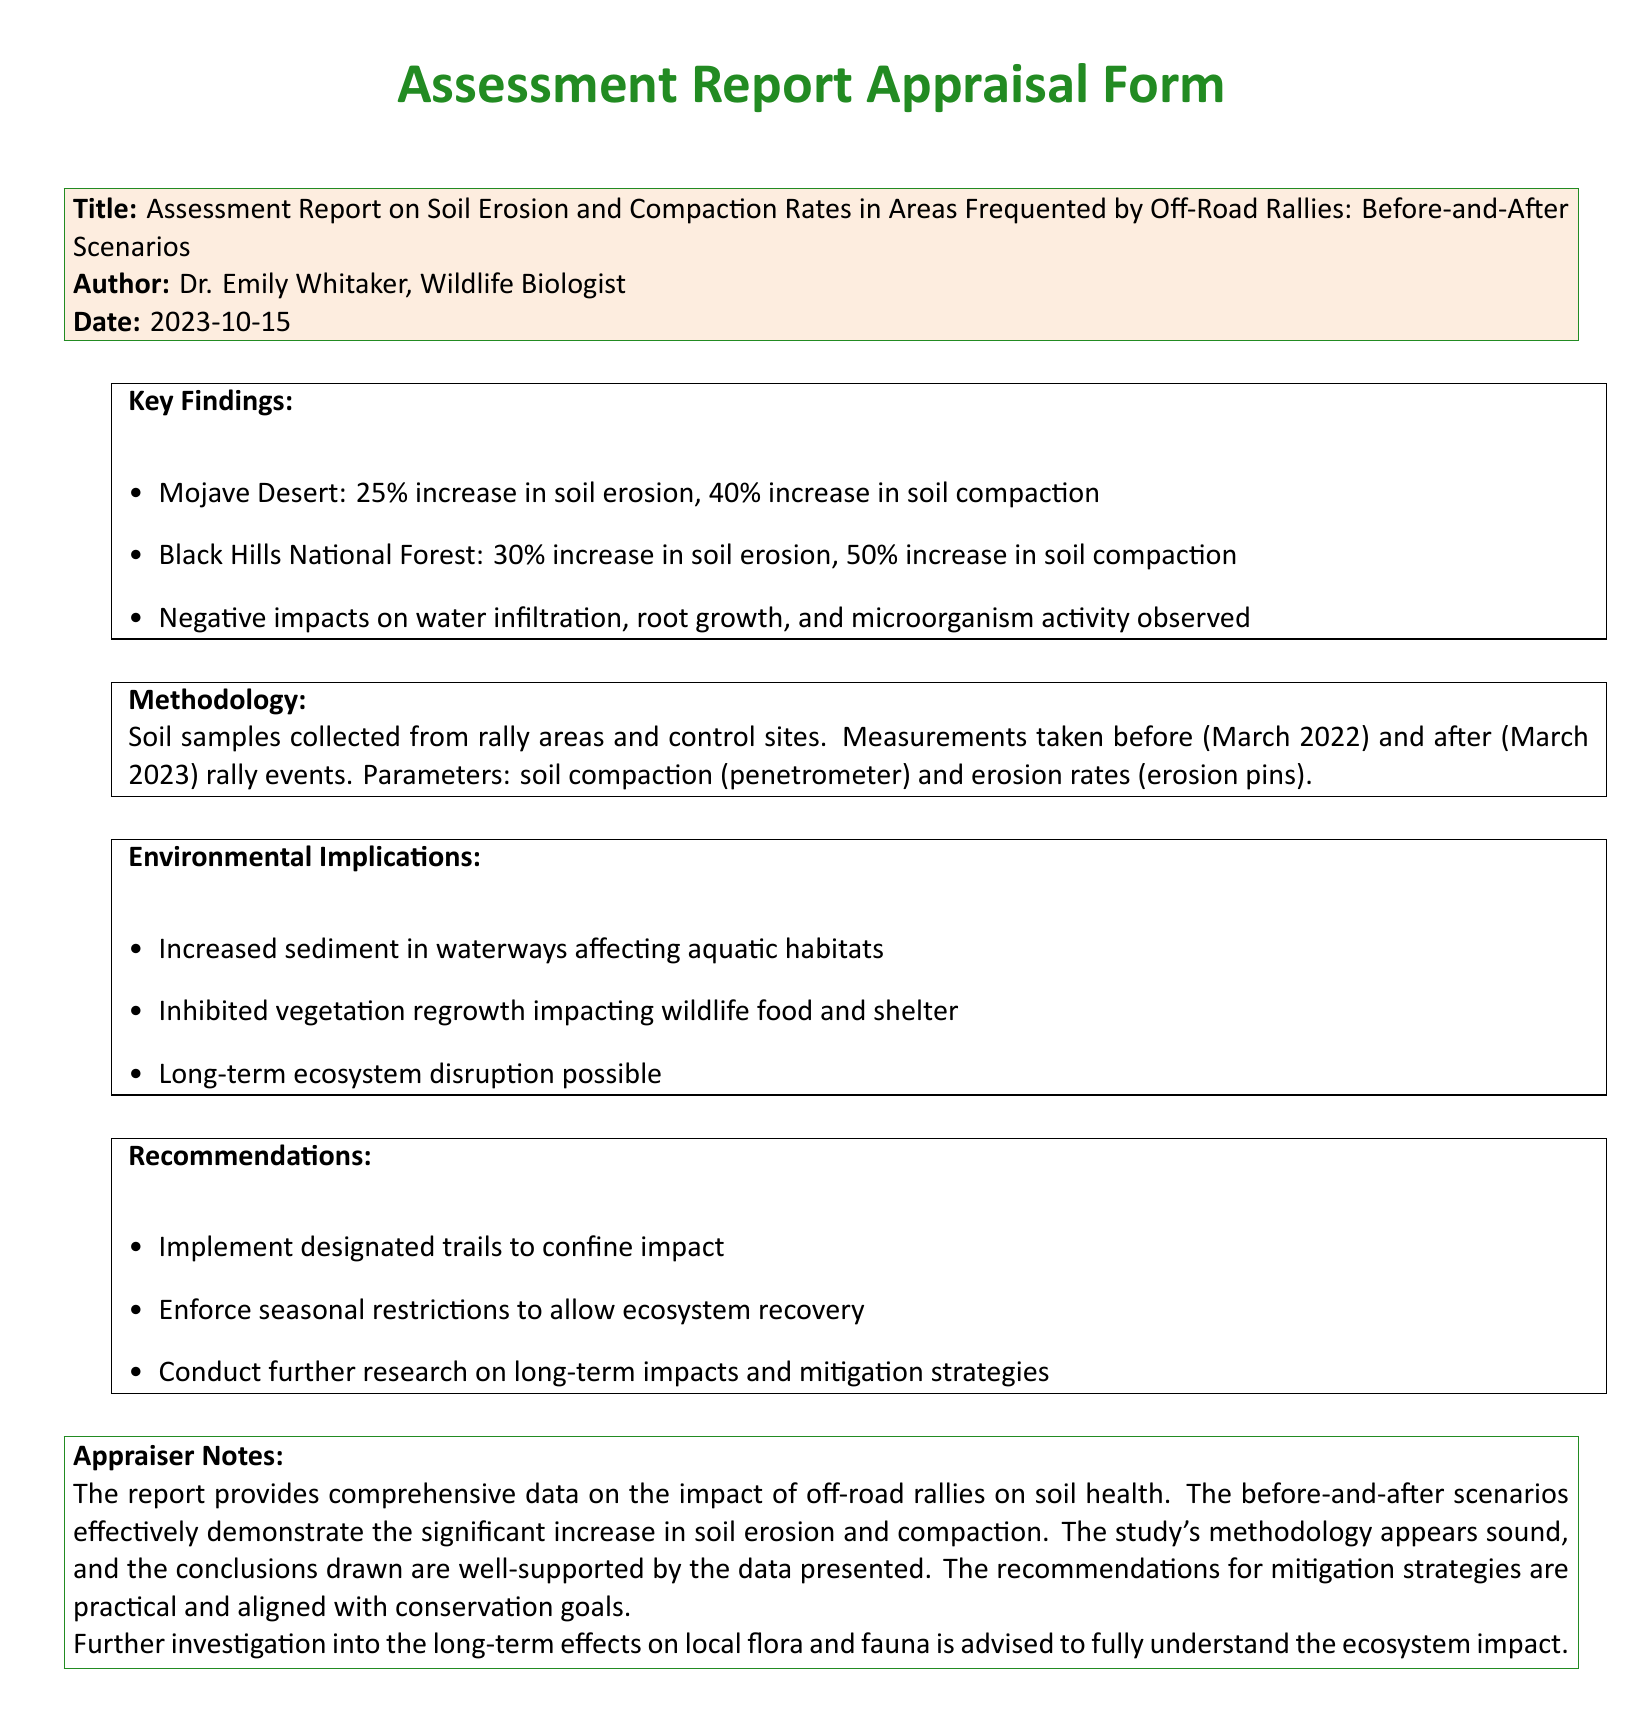What is the title of the report? The title of the report is presented under the Title section of the form.
Answer: Assessment Report on Soil Erosion and Compaction Rates in Areas Frequented by Off-Road Rallies: Before-and-After Scenarios Who is the author of the report? The author is listed directly below the title in the Appraisal form.
Answer: Dr. Emily Whitaker What date was the report published? The publication date appears in the date section of the form.
Answer: 2023-10-15 What was the percentage increase in soil erosion in the Mojave Desert? This information can be found in the Key Findings section of the report.
Answer: 25% What were the methodology parameters used in the study? The parameters are described in the Methodology section of the report.
Answer: Soil compaction (penetrometer) and erosion rates (erosion pins) What are the environmental implications mentioned in the report? The implications are listed in the Environmental Implications section of the report.
Answer: Increased sediment in waterways affecting aquatic habitats What recommendations are provided in the report? The recommendations can be found in the Recommendations section, where mitigation strategies are suggested.
Answer: Implement designated trails to confine impact How much did soil compaction increase in the Black Hills National Forest? This data is provided under the Key Findings section for specific areas.
Answer: 50% What is the purpose of the Appraiser Notes? The purpose of these notes is to provide an evaluation of the report's findings and methodology.
Answer: Evaluation of the report's findings and methodology 